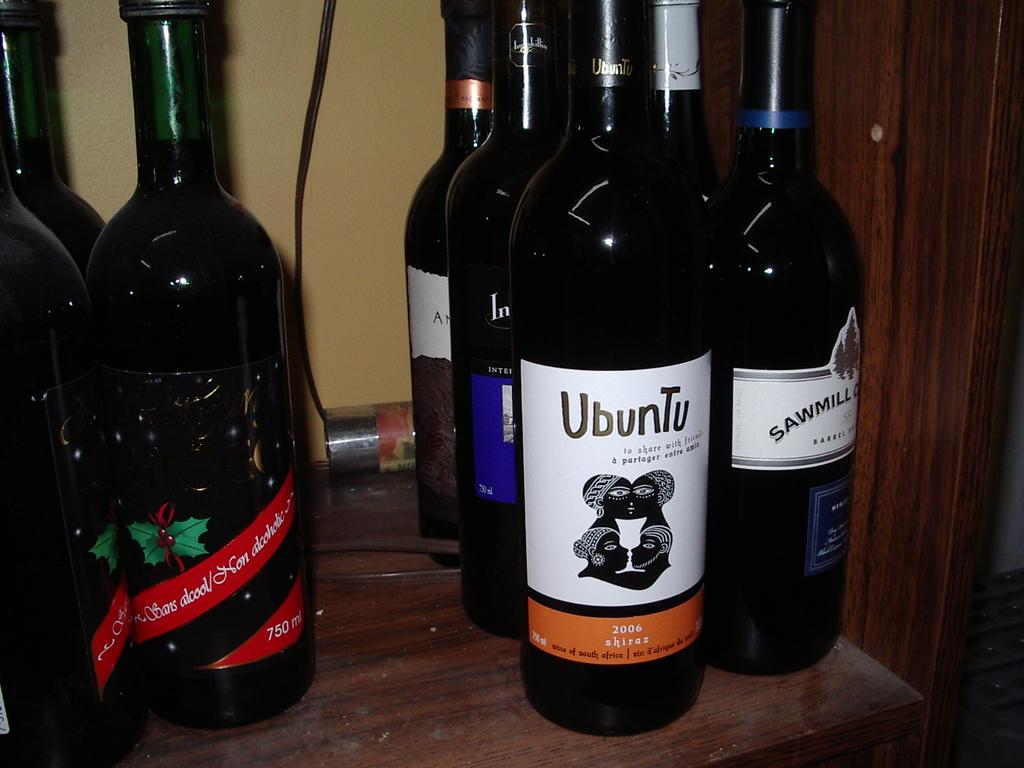<image>
Create a compact narrative representing the image presented. Several different bottles of alcohol are lined up to a wall with a bottle of ubuntu on the front. 